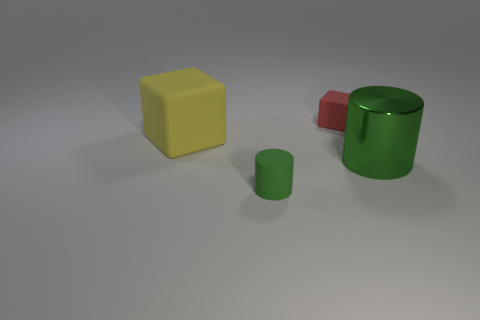Add 3 large cyan matte balls. How many objects exist? 7 Subtract all gray metallic cylinders. Subtract all small matte cylinders. How many objects are left? 3 Add 1 big matte blocks. How many big matte blocks are left? 2 Add 4 red objects. How many red objects exist? 5 Subtract 0 brown cylinders. How many objects are left? 4 